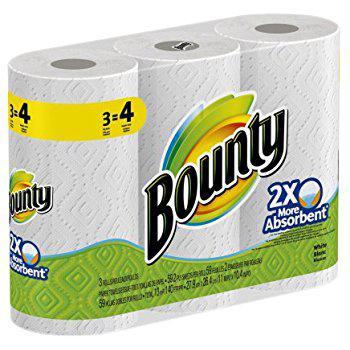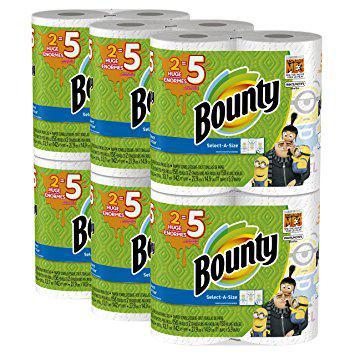The first image is the image on the left, the second image is the image on the right. For the images shown, is this caption "A single package of paper towels stands alone in the image on the left." true? Answer yes or no. Yes. The first image is the image on the left, the second image is the image on the right. Assess this claim about the two images: "The left-hand image shows exactly one multi-pack of paper towels.". Correct or not? Answer yes or no. Yes. 